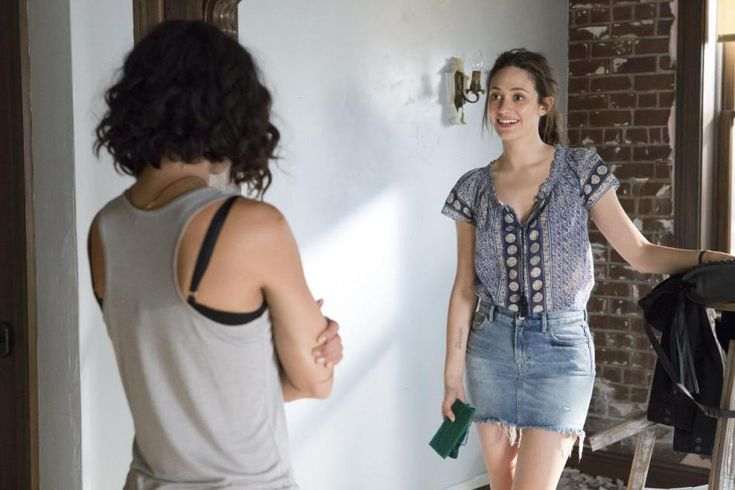Can you provide a detailed description of the setting and mood in this image? In this image, the setting appears to be a cozy, eclectic room with a mix of rustic and modern elements. The brick wall adds a touch of vintage charm, while the wooden bench and ladder suggest a casual and lived-in space. The lighting is soft, contributing to an intimate and warm ambiance. The overall mood is relaxed and friendly, underscored by the smiling woman on the right and her engaging posture as she talks to the other person. This scene feels like a snapshot of an everyday, yet meaningful moment between friends. 